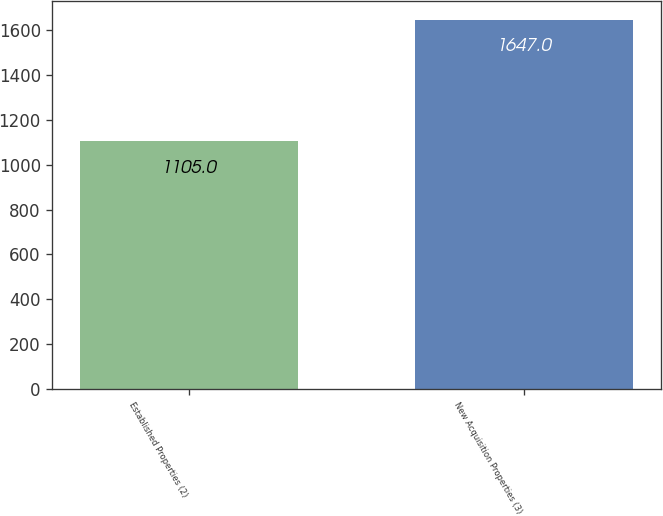<chart> <loc_0><loc_0><loc_500><loc_500><bar_chart><fcel>Established Properties (2)<fcel>New Acquisition Properties (3)<nl><fcel>1105<fcel>1647<nl></chart> 